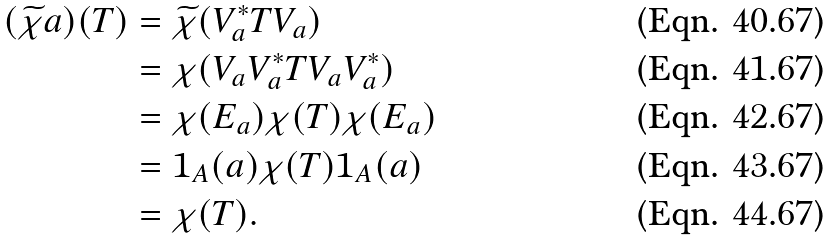Convert formula to latex. <formula><loc_0><loc_0><loc_500><loc_500>( \widetilde { \chi } a ) ( T ) & = \widetilde { \chi } ( V _ { a } ^ { * } T V _ { a } ) \\ & = \chi ( V _ { a } V _ { a } ^ { * } T V _ { a } V _ { a } ^ { * } ) \\ & = \chi ( E _ { a } ) \chi ( T ) \chi ( E _ { a } ) \\ & = 1 _ { A } ( a ) \chi ( T ) 1 _ { A } ( a ) \\ & = \chi ( T ) .</formula> 